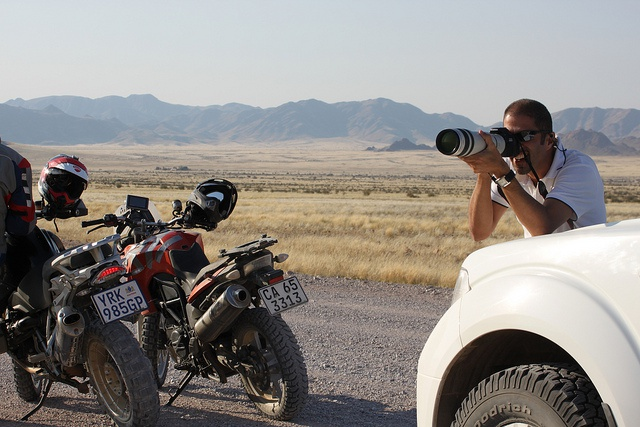Describe the objects in this image and their specific colors. I can see car in lightgray, black, gray, and darkgray tones, motorcycle in lightgray, black, gray, maroon, and darkgray tones, motorcycle in lightgray, black, and gray tones, people in lightgray, black, gray, maroon, and brown tones, and backpack in lightgray, black, maroon, gray, and brown tones in this image. 